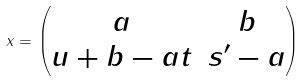<formula> <loc_0><loc_0><loc_500><loc_500>x = \begin{pmatrix} a & b \\ u + b - a t & s ^ { \prime } - a \end{pmatrix}</formula> 